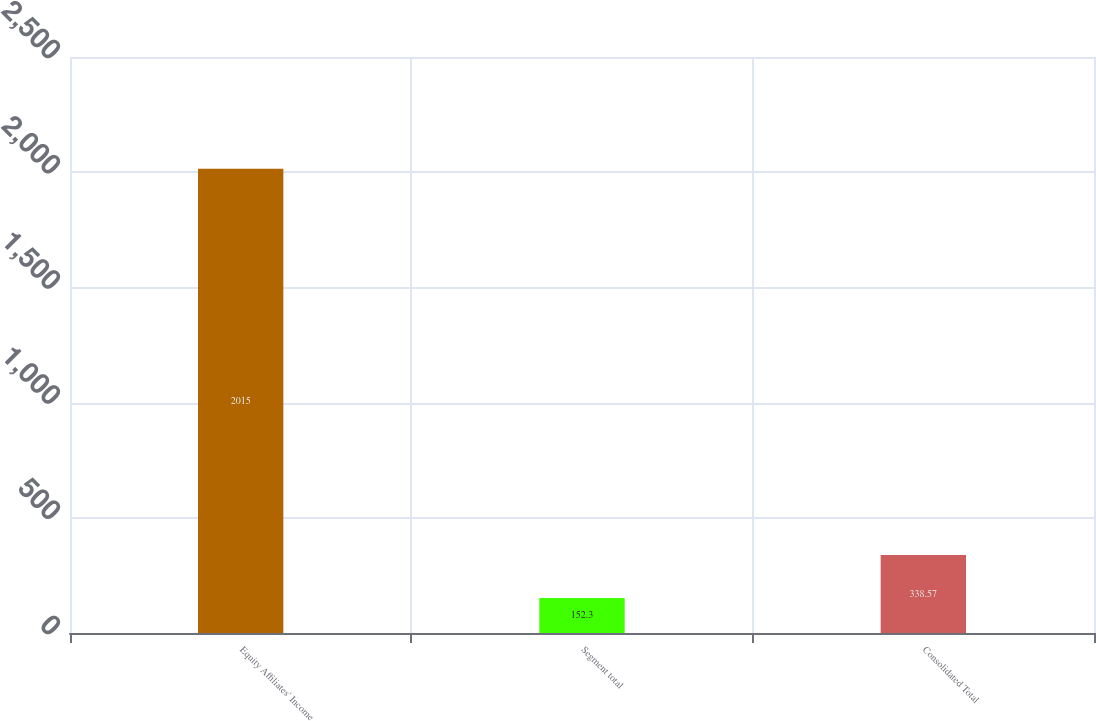Convert chart. <chart><loc_0><loc_0><loc_500><loc_500><bar_chart><fcel>Equity Affiliates' Income<fcel>Segment total<fcel>Consolidated Total<nl><fcel>2015<fcel>152.3<fcel>338.57<nl></chart> 